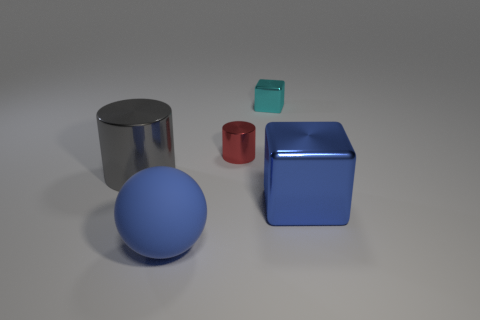What number of other things are there of the same size as the matte sphere? Including the matte sphere, there are three objects that appear to be of a similar scale in the image: the sphere itself, a smaller shiny cylinder, and a small cube. It's important to note that since the image doesn't provide exact measurements, the assessment of size is based on visual estimation. 